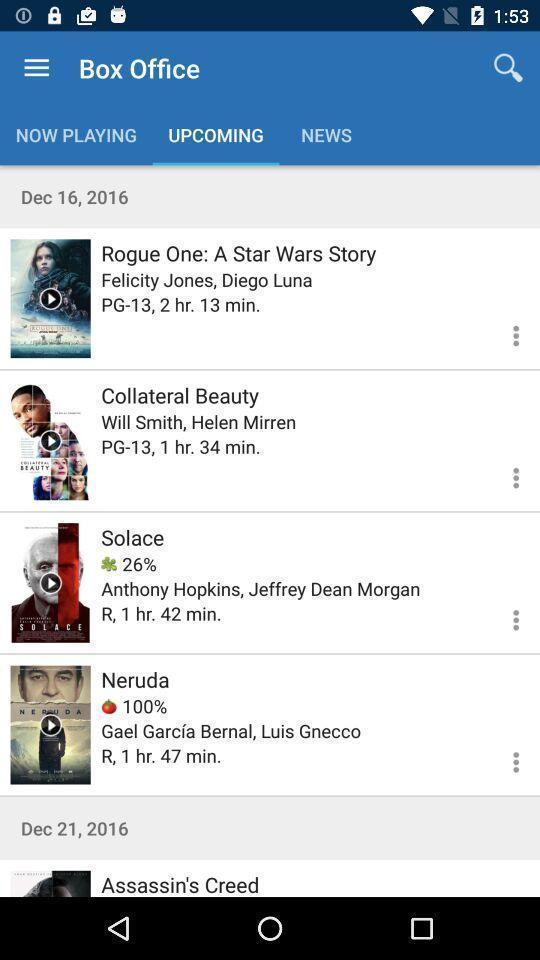Provide a description of this screenshot. Screen displaying upcoming movies on movie streaming app. 